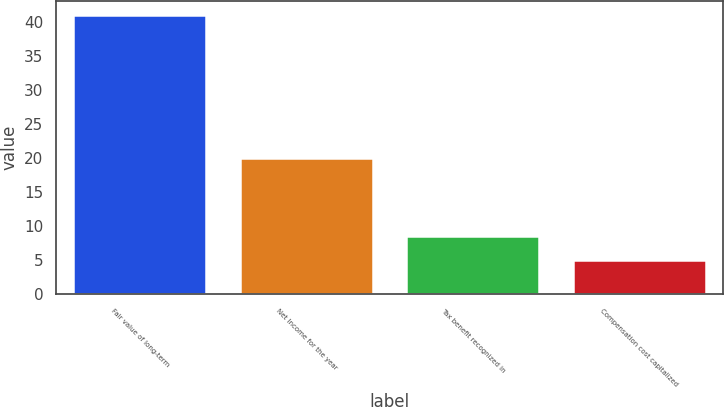Convert chart. <chart><loc_0><loc_0><loc_500><loc_500><bar_chart><fcel>Fair value of long-term<fcel>Net Income for the year<fcel>Tax benefit recognized in<fcel>Compensation cost capitalized<nl><fcel>41<fcel>20<fcel>8.6<fcel>5<nl></chart> 